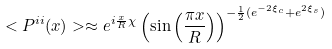<formula> <loc_0><loc_0><loc_500><loc_500>< P ^ { i i } ( x ) > \approx e ^ { i { \frac { x } { R } } \chi } \left ( \sin { \left ( \frac { \pi x } { R } \right ) } \right ) ^ { - { \frac { 1 } { 2 } } ( e ^ { - 2 \xi _ { c } } + e ^ { 2 \xi _ { s } } ) }</formula> 